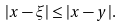Convert formula to latex. <formula><loc_0><loc_0><loc_500><loc_500>| x - \xi | \leq | x - y | .</formula> 